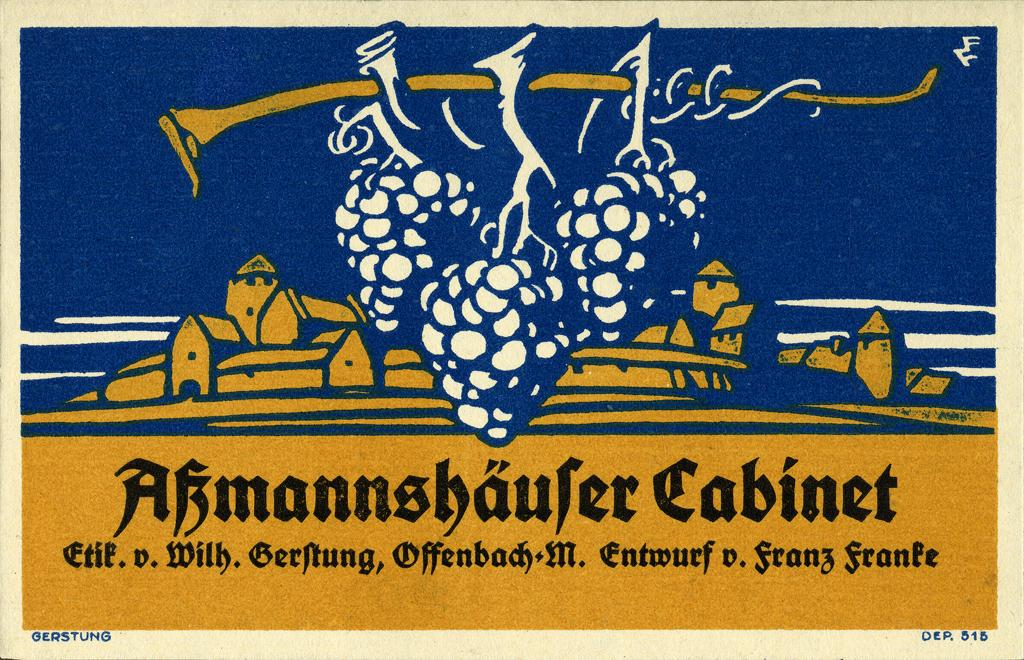<image>
Share a concise interpretation of the image provided. Made by Gerstung is a piece of yellow, blue and white peace of art showing a village in the distance with hanging grapes in the forefront. 